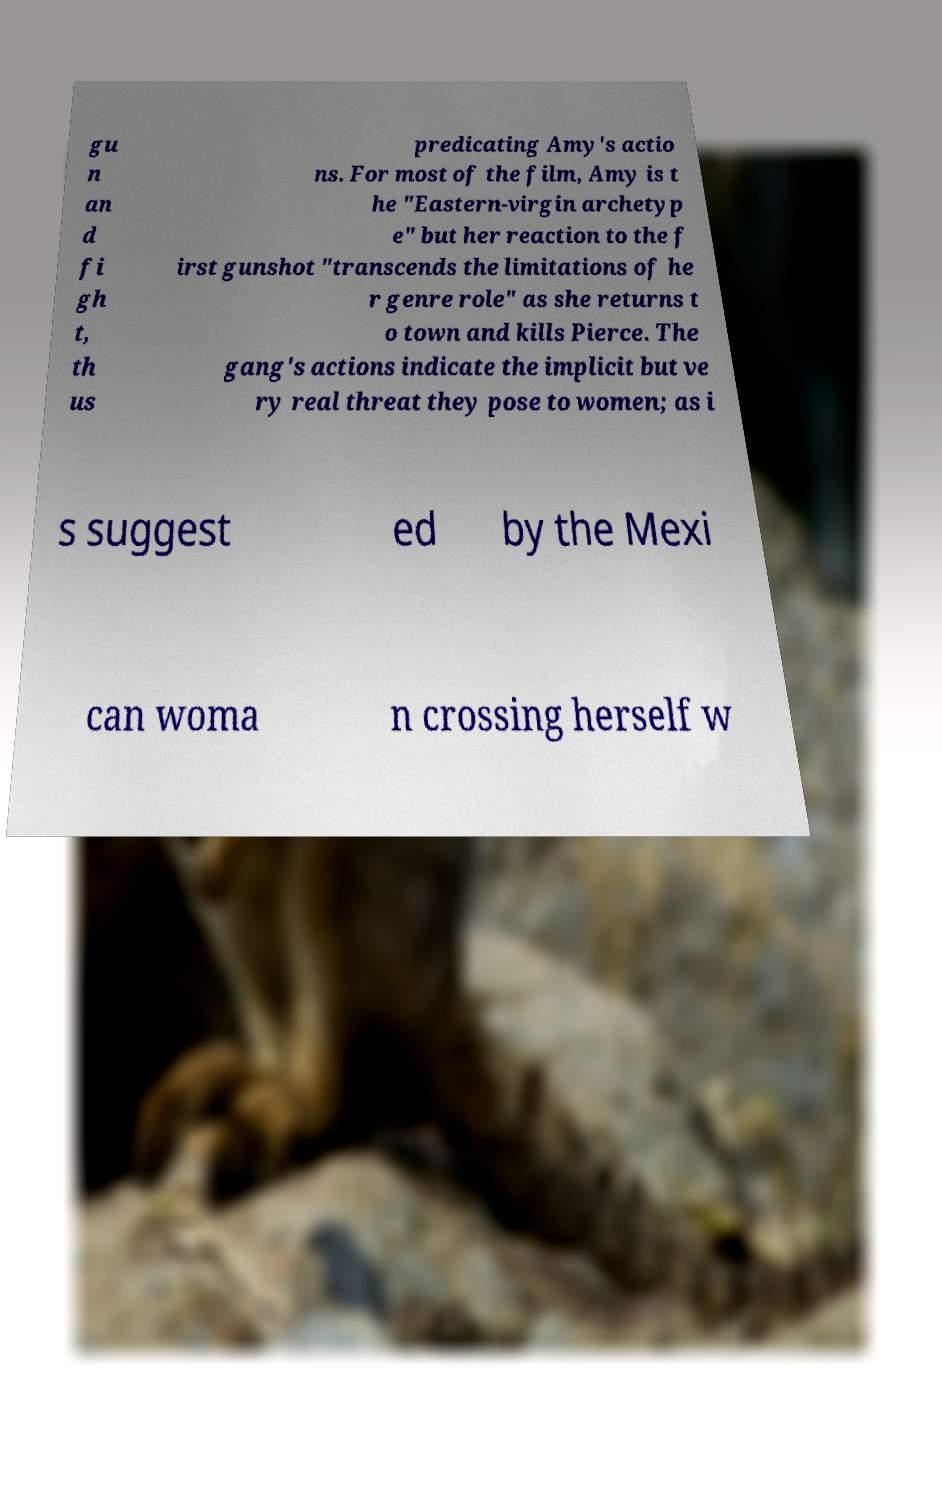Can you read and provide the text displayed in the image?This photo seems to have some interesting text. Can you extract and type it out for me? gu n an d fi gh t, th us predicating Amy's actio ns. For most of the film, Amy is t he "Eastern-virgin archetyp e" but her reaction to the f irst gunshot "transcends the limitations of he r genre role" as she returns t o town and kills Pierce. The gang's actions indicate the implicit but ve ry real threat they pose to women; as i s suggest ed by the Mexi can woma n crossing herself w 